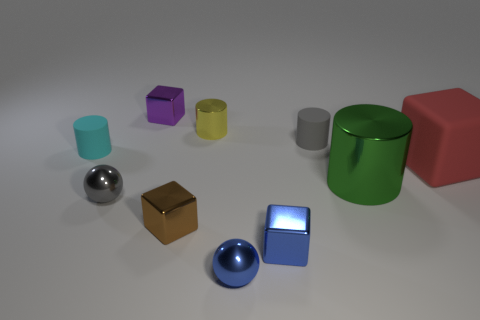Is the cube in the center of the image perfectly aligned with the other shapes? The cube seems to be deliberately placed near the center, but it is not perfectly aligned with all the other shapes; they are arranged at various angles and distances. 